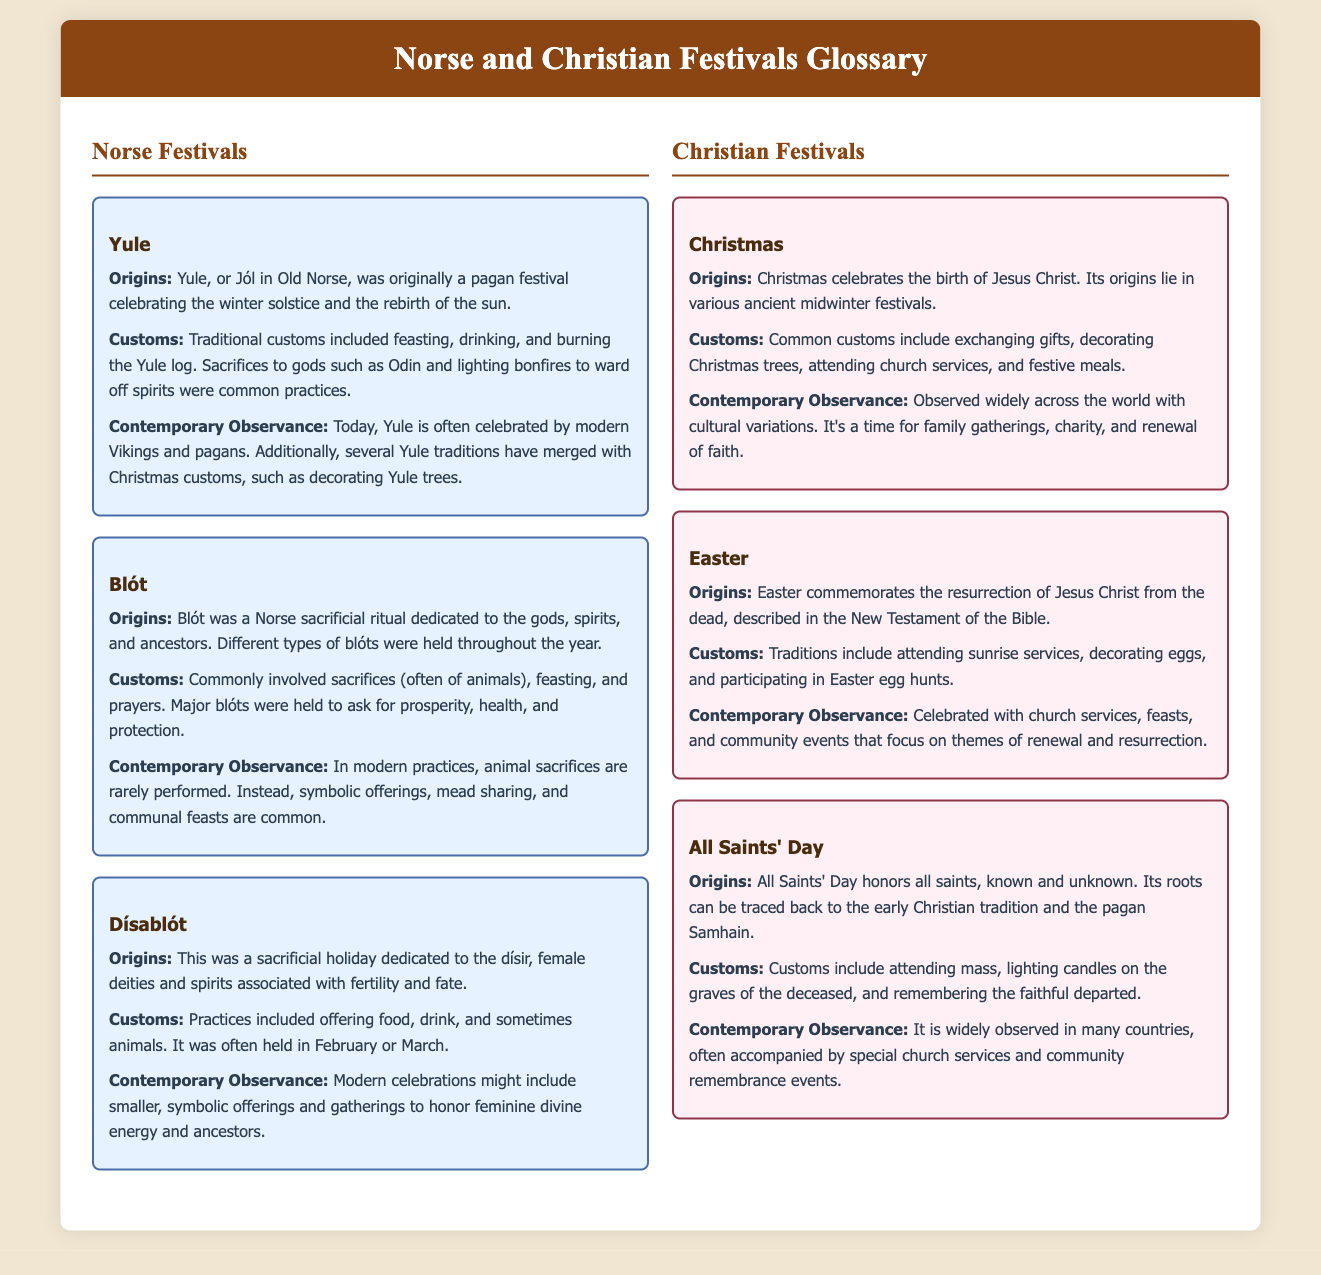What is celebrated during Yule? Yule celebrates the winter solstice and the rebirth of the sun.
Answer: winter solstice and the rebirth of the sun What type of ritual is Blót? Blót is a Norse sacrificial ritual dedicated to the gods, spirits, and ancestors.
Answer: sacrificial ritual When is Dísablót commonly held? Dísablót was often held in February or March.
Answer: February or March What does Christmas celebrate? Christmas celebrates the birth of Jesus Christ.
Answer: birth of Jesus Christ What common custom is associated with Easter? A common custom of Easter includes decorating eggs.
Answer: decorating eggs What type of event is All Saints' Day? All Saints' Day honors all saints, known and unknown.
Answer: honors all saints What is a contemporary observance of Yule? Today, Yule is often celebrated by modern Vikings and pagans.
Answer: celebrated by modern Vikings and pagans What does Easter commemorate? Easter commemorates the resurrection of Jesus Christ from the dead.
Answer: resurrection of Jesus Christ What kind of offerings were made during Dísablót? Practices included offering food, drink, and sometimes animals.
Answer: food, drink, and sometimes animals 